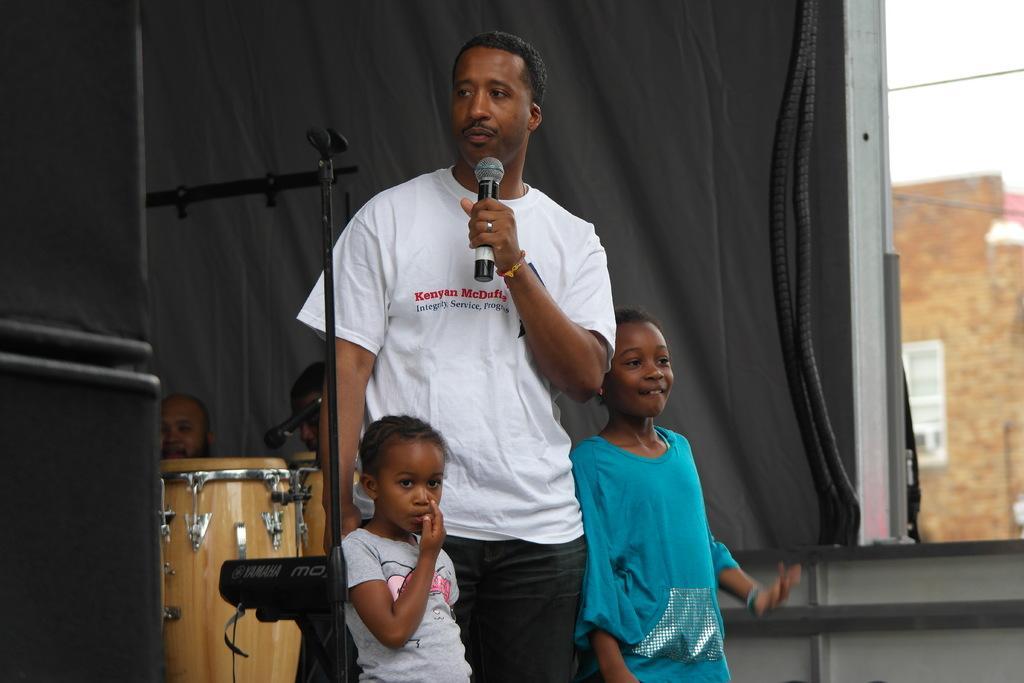Can you describe this image briefly? in this image i can see a person standing, wearing a white t shirt and holding a microphone in his hand. two children are standing at the left and right to him. behind him there are drums. 